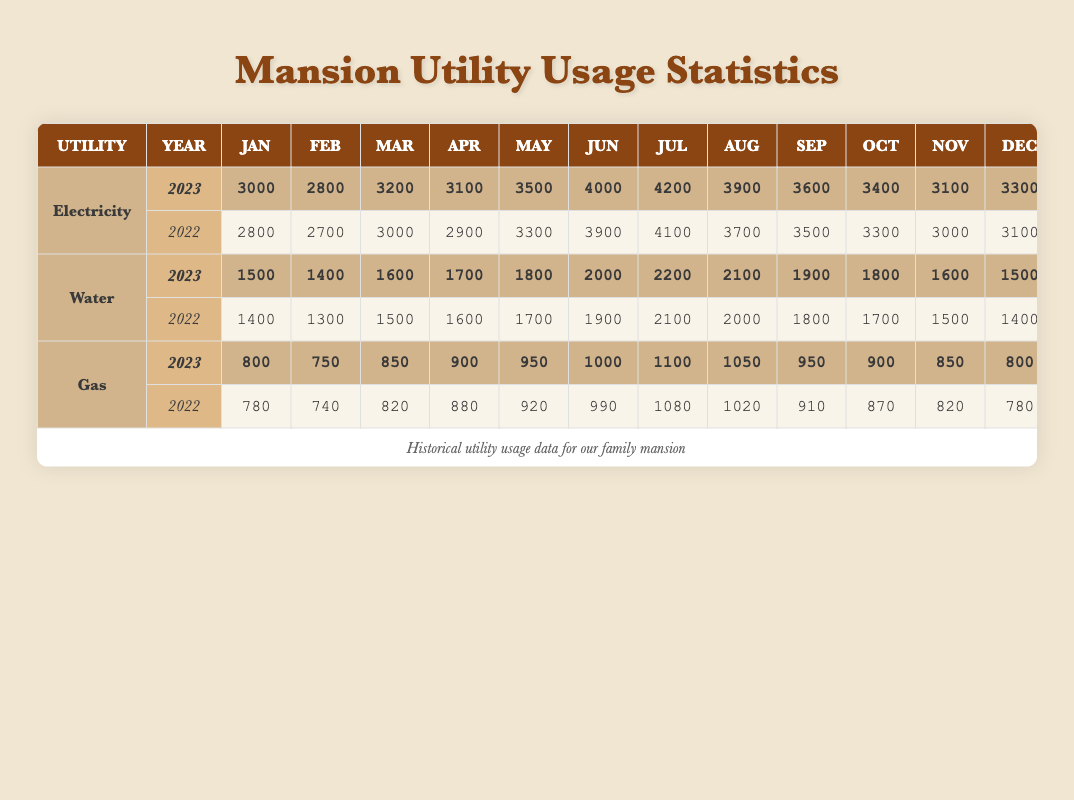What was the total electricity usage in July 2023? To find the total electricity usage in July 2023, I can directly look up the value in the table. It shows that the usage in July 2023 was 4200.
Answer: 4200 Which month had the highest water usage in 2022? By examining the water usage data for 2022, I can compare the values. The highest usage was in July with 2100.
Answer: July What is the difference in gas usage between January 2022 and January 2023? I subtract January 2022 gas usage (780) from January 2023 gas usage (800): 800 - 780 = 20.
Answer: 20 Did the electricity usage increase from 2022 to 2023 in October? I compare the electricity usage for October of both years: 2023 shows 3400, and 2022 shows 3300. Since 3400 is greater, the usage did increase.
Answer: Yes What is the average monthly water usage for 2023? First, I sum up all the monthly water usage values for 2023 (1500 + 1400 + 1600 + 1700 + 1800 + 2000 + 2200 + 2100 + 1900 + 1800 + 1600 + 1500 = 20000) and then divide by 12 (20000 / 12 = 1666.67).
Answer: 1666.67 In which month was gas usage the lowest in 2022? I review the gas usage values for each month in 2022. The lowest was in February, with a usage of 740.
Answer: February What was the total utility usage (Electricity, Water, and Gas) for June 2023? I need to find the individual utility usage for June 2023 and then sum them up: electricity (4000) + water (2000) + gas (1000) = 7000.
Answer: 7000 Has the mansion's water usage in April increased or decreased from 2022 to 2023? In April 2022, the usage was 1600, and in April 2023, it is now 1700. Since 1700 is greater than 1600, the usage has increased.
Answer: Increased What month in 2023 had the lowest electricity usage? I can look at the monthly electricity usage for 2023 and see that the lowest was in February with a usage of 2800.
Answer: February 